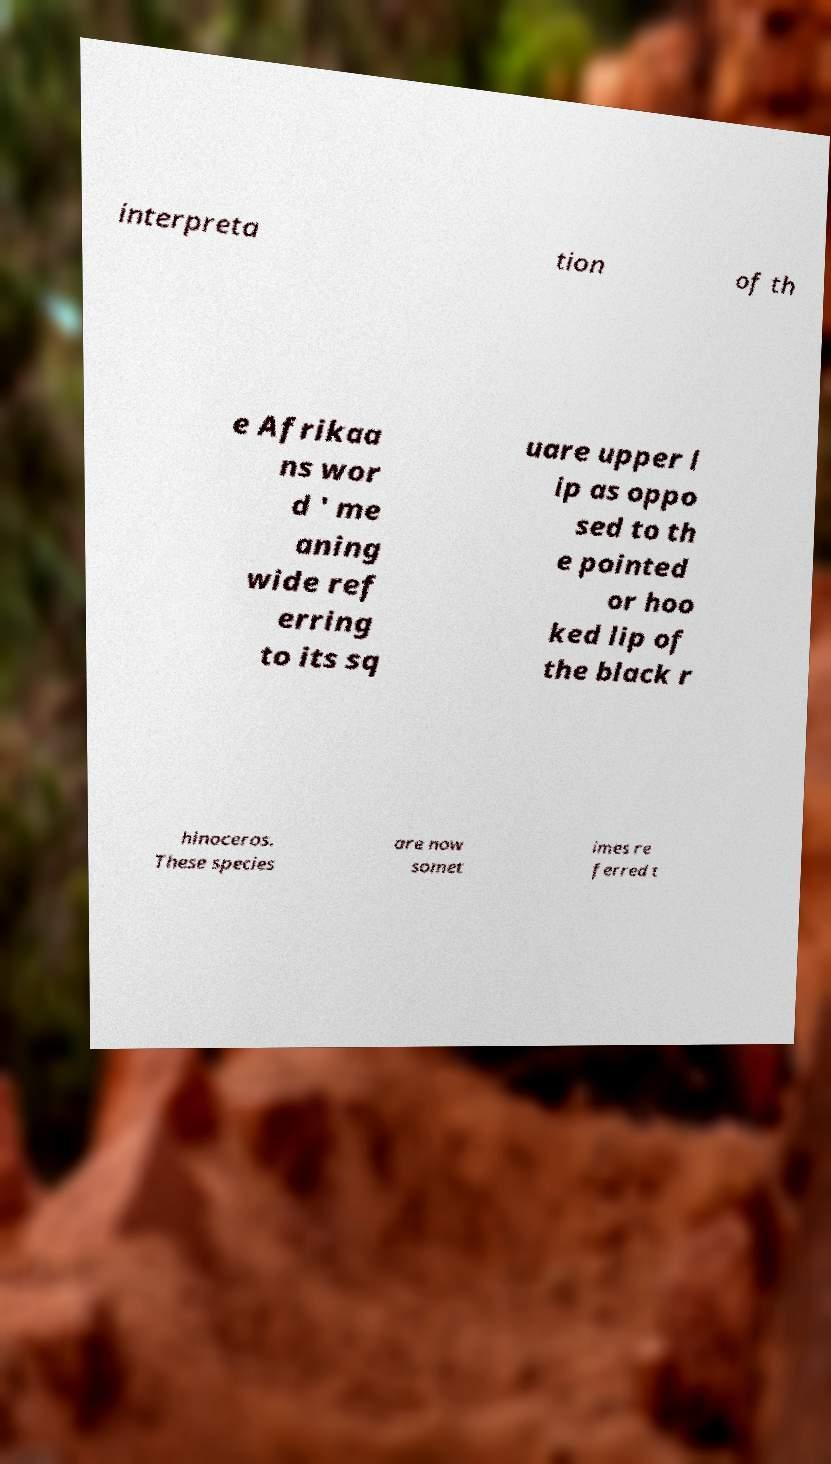Please read and relay the text visible in this image. What does it say? interpreta tion of th e Afrikaa ns wor d ' me aning wide ref erring to its sq uare upper l ip as oppo sed to th e pointed or hoo ked lip of the black r hinoceros. These species are now somet imes re ferred t 